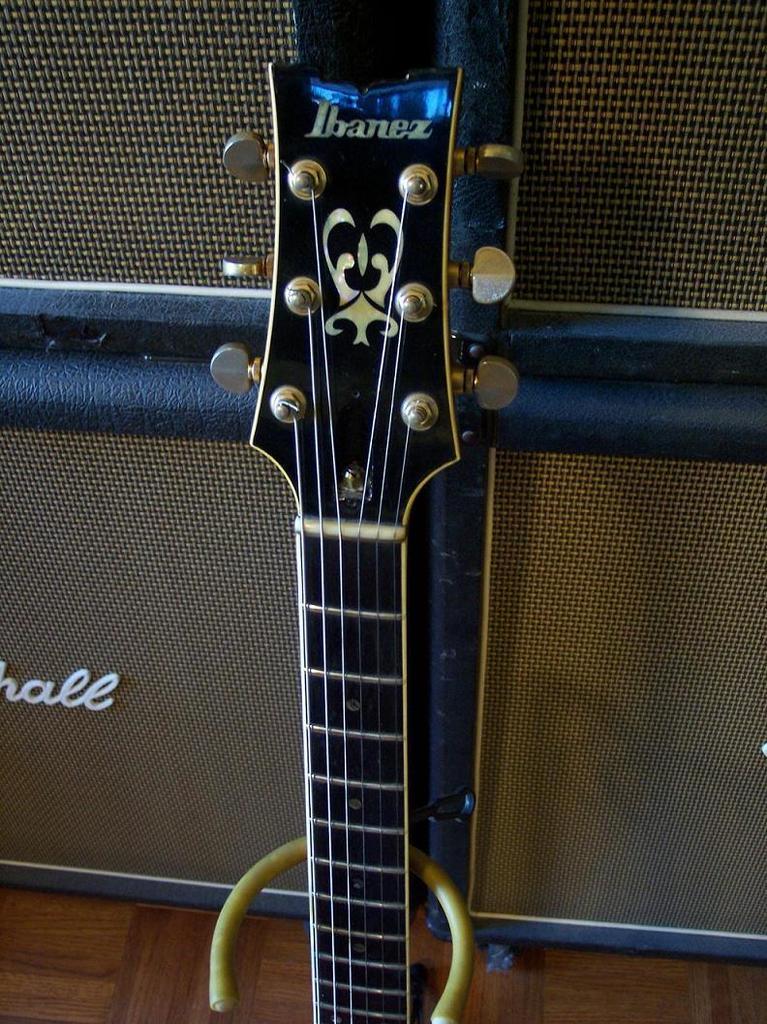Can you describe this image briefly? This is a guitar head. On the background there is a wall. 